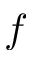<formula> <loc_0><loc_0><loc_500><loc_500>f</formula> 